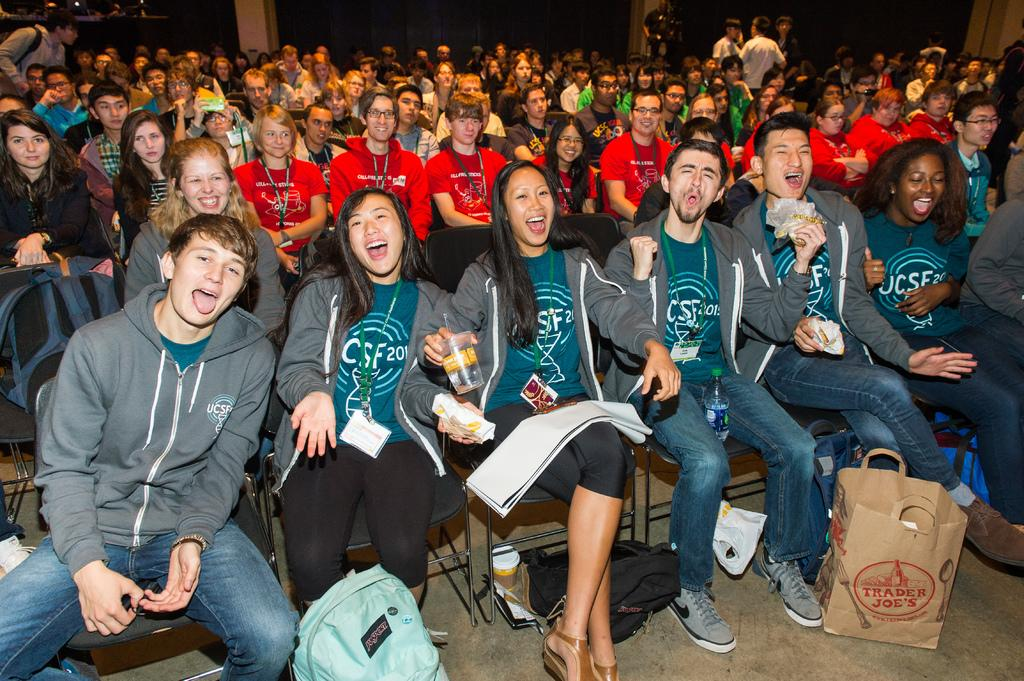How many people are in the image? There is a group of people in the image, but the exact number is not specified. What are the people doing in the image? The people are sitting on chairs in the image. What are some people holding in their hands? Some people are holding objects in their hands, but the specific objects are not described. What type of bags can be seen in the image? There are bags visible in the image, but their contents or type are not specified. Can you describe any other objects present in the image? There are other objects present in the image, but their nature or purpose is not described. What type of leaf is being used as a territory marker in the image? There is no leaf or territory marker present in the image. Can you describe the spacecraft visible in the image? There is no spacecraft present in the image. 